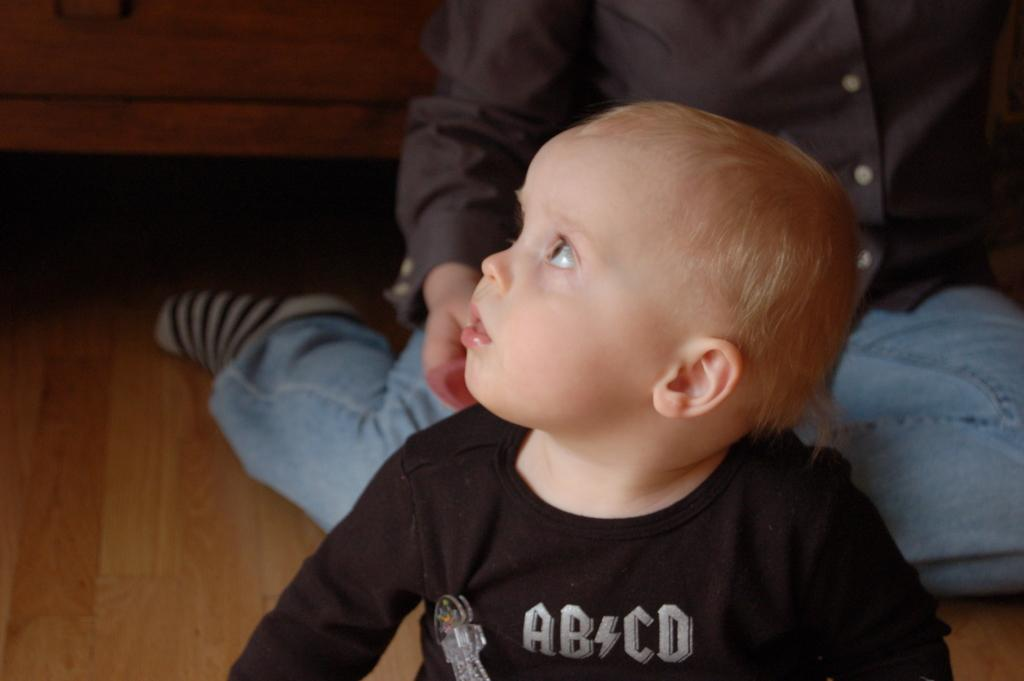What is the primary subject in the image? There is a child in the image. Can you describe the position of the person in the image? There is a person on the floor in the image. What type of object can be seen in the background of the image? There is a wooden object visible in the background of the image. What type of needle is the child using to sew in the image? There is no needle present in the image; the child is not sewing. 